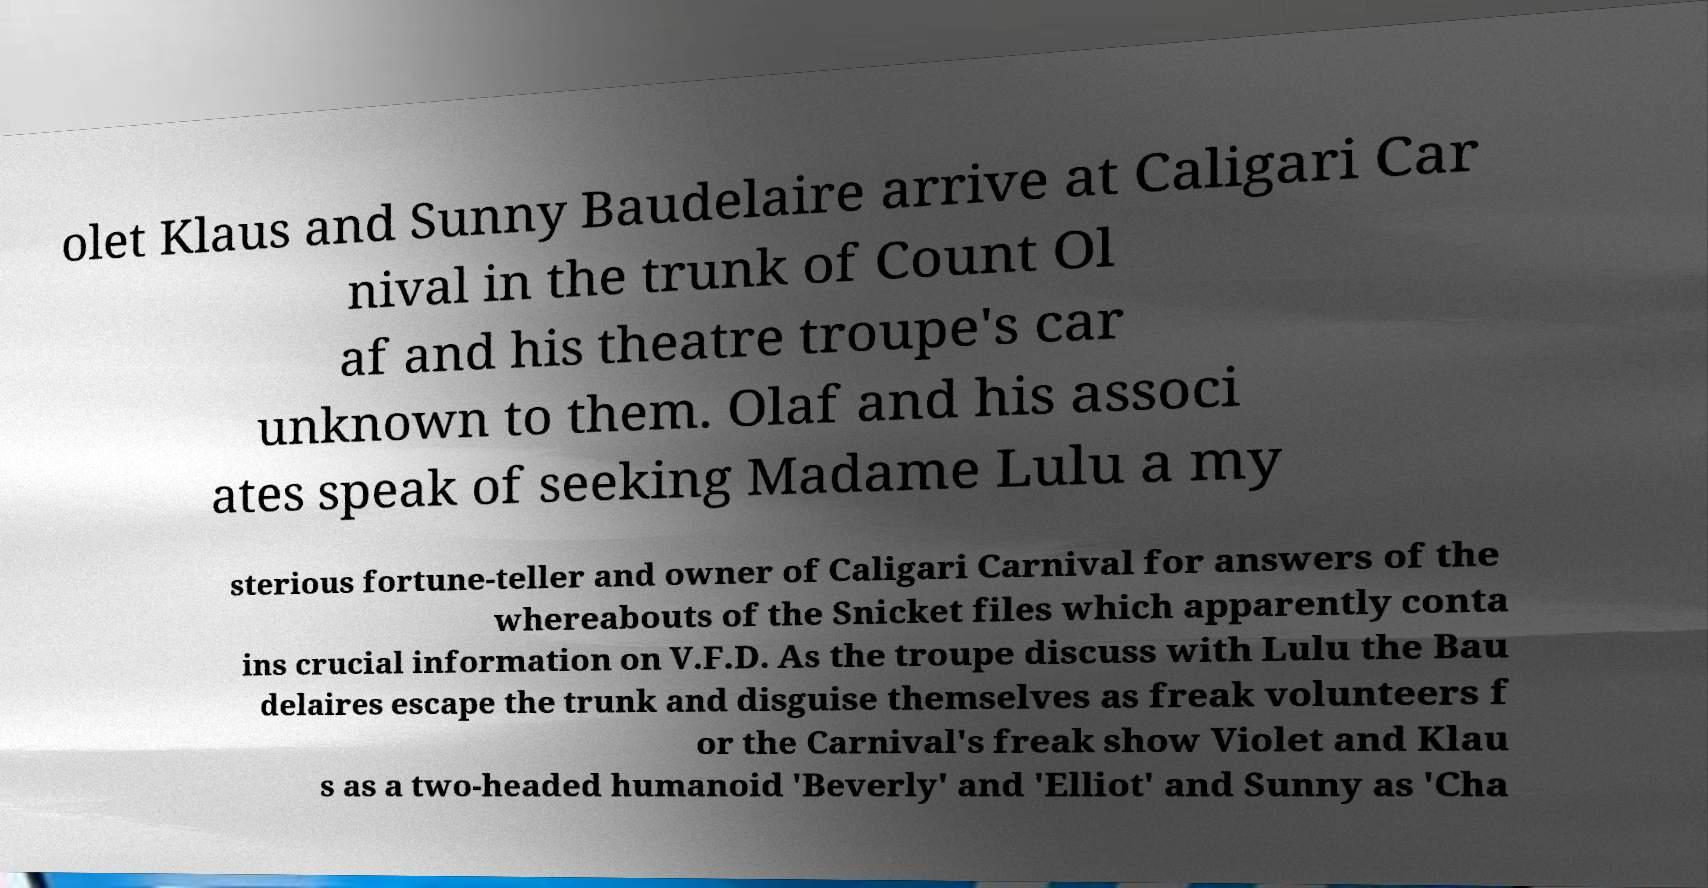Could you assist in decoding the text presented in this image and type it out clearly? olet Klaus and Sunny Baudelaire arrive at Caligari Car nival in the trunk of Count Ol af and his theatre troupe's car unknown to them. Olaf and his associ ates speak of seeking Madame Lulu a my sterious fortune-teller and owner of Caligari Carnival for answers of the whereabouts of the Snicket files which apparently conta ins crucial information on V.F.D. As the troupe discuss with Lulu the Bau delaires escape the trunk and disguise themselves as freak volunteers f or the Carnival's freak show Violet and Klau s as a two-headed humanoid 'Beverly' and 'Elliot' and Sunny as 'Cha 